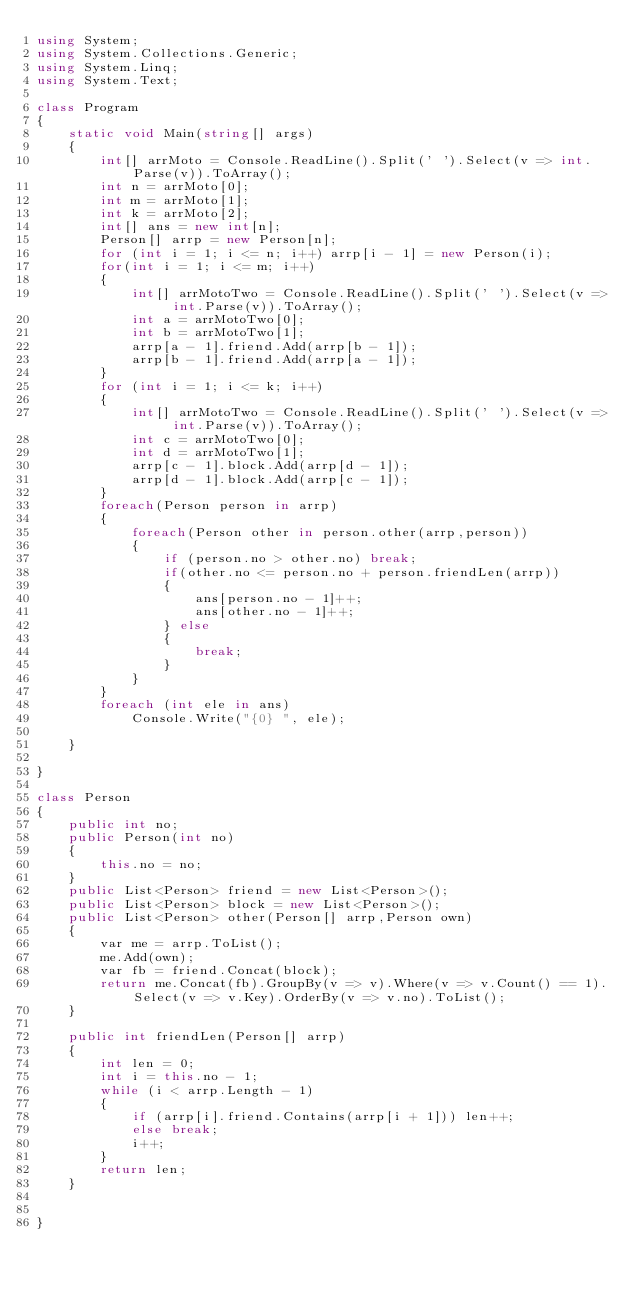Convert code to text. <code><loc_0><loc_0><loc_500><loc_500><_C#_>using System;
using System.Collections.Generic;
using System.Linq;
using System.Text;

class Program
{
    static void Main(string[] args)
    {
        int[] arrMoto = Console.ReadLine().Split(' ').Select(v => int.Parse(v)).ToArray();
        int n = arrMoto[0];
        int m = arrMoto[1];
        int k = arrMoto[2];
        int[] ans = new int[n];
        Person[] arrp = new Person[n];
        for (int i = 1; i <= n; i++) arrp[i - 1] = new Person(i);
        for(int i = 1; i <= m; i++)
        {
            int[] arrMotoTwo = Console.ReadLine().Split(' ').Select(v => int.Parse(v)).ToArray();
            int a = arrMotoTwo[0];
            int b = arrMotoTwo[1];
            arrp[a - 1].friend.Add(arrp[b - 1]);
            arrp[b - 1].friend.Add(arrp[a - 1]);
        }
        for (int i = 1; i <= k; i++)
        {
            int[] arrMotoTwo = Console.ReadLine().Split(' ').Select(v => int.Parse(v)).ToArray();
            int c = arrMotoTwo[0];
            int d = arrMotoTwo[1];
            arrp[c - 1].block.Add(arrp[d - 1]);
            arrp[d - 1].block.Add(arrp[c - 1]);
        }
        foreach(Person person in arrp)
        {
            foreach(Person other in person.other(arrp,person))
            {
                if (person.no > other.no) break;
                if(other.no <= person.no + person.friendLen(arrp))
                {
                    ans[person.no - 1]++;
                    ans[other.no - 1]++;
                } else
                {
                    break;
                }
            }
        }
        foreach (int ele in ans)
            Console.Write("{0} ", ele);

    }

}

class Person
{
    public int no;
    public Person(int no)
    {
        this.no = no;
    }
    public List<Person> friend = new List<Person>();
    public List<Person> block = new List<Person>();
    public List<Person> other(Person[] arrp,Person own)
    {
        var me = arrp.ToList();
        me.Add(own);
        var fb = friend.Concat(block);
        return me.Concat(fb).GroupBy(v => v).Where(v => v.Count() == 1).Select(v => v.Key).OrderBy(v => v.no).ToList();
    }

    public int friendLen(Person[] arrp)
    {
        int len = 0;
        int i = this.no - 1;
        while (i < arrp.Length - 1)
        {
            if (arrp[i].friend.Contains(arrp[i + 1])) len++;
            else break;
            i++;
        }
        return len;
    }


}



</code> 